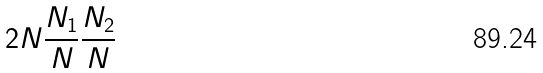Convert formula to latex. <formula><loc_0><loc_0><loc_500><loc_500>2 N \frac { N _ { 1 } } { N } \frac { N _ { 2 } } { N }</formula> 